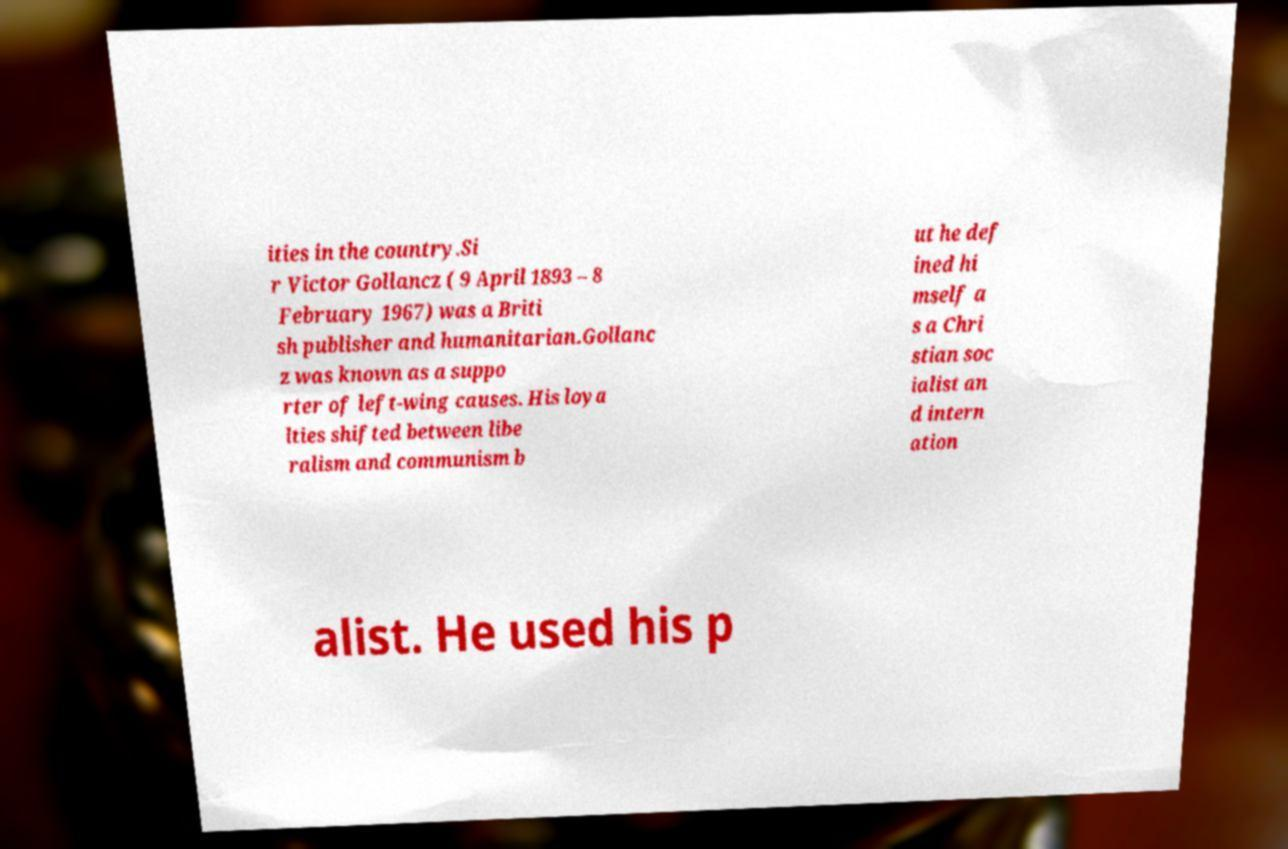I need the written content from this picture converted into text. Can you do that? ities in the country.Si r Victor Gollancz ( 9 April 1893 – 8 February 1967) was a Briti sh publisher and humanitarian.Gollanc z was known as a suppo rter of left-wing causes. His loya lties shifted between libe ralism and communism b ut he def ined hi mself a s a Chri stian soc ialist an d intern ation alist. He used his p 